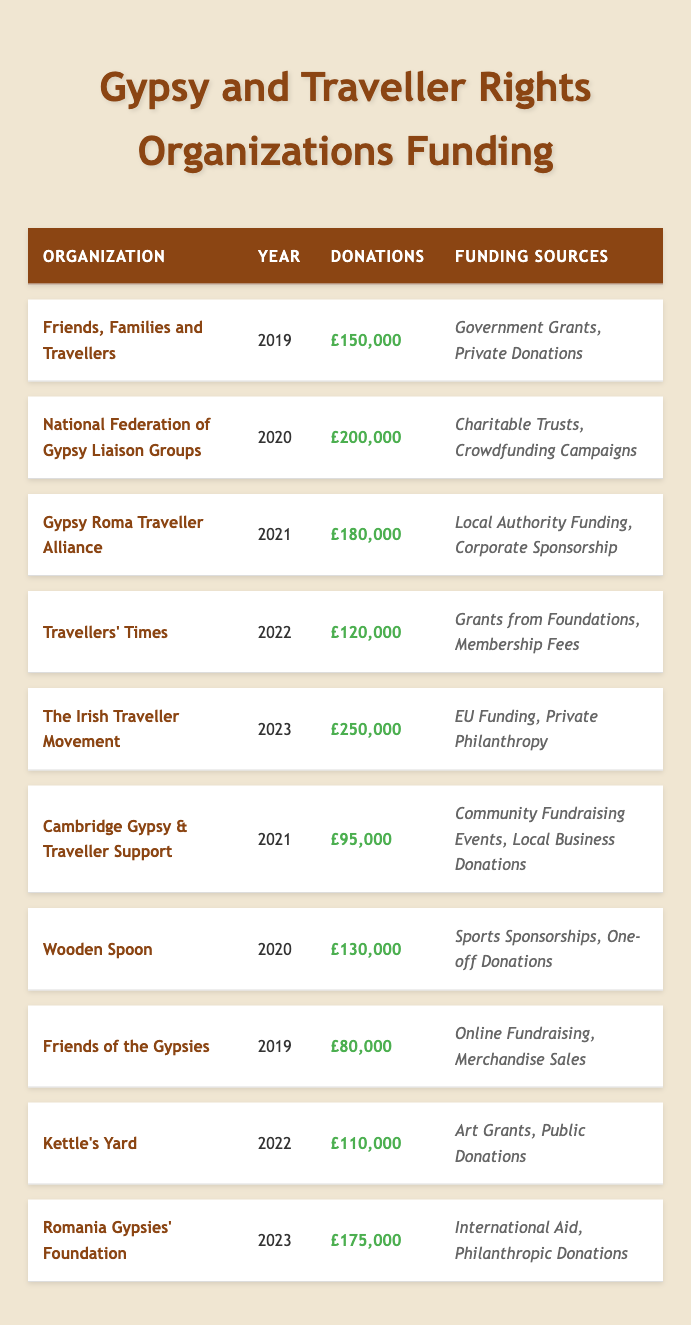What was the total amount of donations for 2020? In 2020, the donations were £200,000 from the National Federation of Gypsy Liaison Groups and £130,000 from Wooden Spoon. Summing these amounts gives £200,000 + £130,000 = £330,000.
Answer: £330,000 Which organization received the highest donations in 2023? The Irish Traveller Movement received the highest donations in 2023, totaling £250,000.
Answer: The Irish Traveller Movement How many organizations got funding from private donations? Friends, Families and Travellers, The Irish Traveller Movement, and Friends of the Gypsies received funding from private donations. This is a total of three organizations.
Answer: 3 What was the average amount of donations for the organizations in 2021? The organizations in 2021 are Gypsy Roma Traveller Alliance (£180,000) and Cambridge Gypsy & Traveller Support (£95,000). The total donations are £180,000 + £95,000 = £275,000, and there are 2 organizations, so the average is £275,000 / 2 = £137,500.
Answer: £137,500 Which funding source was common for the organizations supported in 2019? The organizations in 2019 were Friends, Families and Travellers and Friends of the Gypsies. Friends, Families and Travellers received funding from Government Grants and Private Donations, while Friends of the Gypsies had Online Fundraising and Merchandise Sales. Thus, there are no common funding sources for the year.
Answer: No What was the total donations amount across all organizations for the year 2022? The organizations in 2022 are Travellers' Times (£120,000) and Kettle's Yard (£110,000). Adding these gives £120,000 + £110,000 = £230,000.
Answer: £230,000 Did any organizations receive funding exclusively from community fundraising events? None of the organizations listed received funding exclusively from community fundraising events; Cambridge Gypsy & Traveller Support received funding from Community Fundraising Events and Local Business Donations, indicating there were other funding sources.
Answer: No Which year had the least amount of total donations and how much was it? In 2019, Friends, Families and Travellers had £150,000 and Friends of the Gypsies had £80,000. The total is £150,000 + £80,000 = £230,000. This is lesser than any other year's total donations.
Answer: £230,000 in 2019 What is the difference in donations between the highest and lowest funded organization in 2023? The Irish Traveller Movement received £250,000 and Romania Gypsies' Foundation received £175,000 in 2023. The difference is £250,000 - £175,000 = £75,000.
Answer: £75,000 Which funding source was the most common across all organizations? By reviewing the funding sources listed, several types appear, but private donations (present in Friends, Families and Travellers; The Irish Traveller Movement) and government grants appear frequently, though other funding types are seen as well. There is no definitive most common source in the dataset.
Answer: Not definitive How many organizations received government grants over the past five years? Only Friends, Families and Travellers received government grants in 2019. None of the remaining organizations listed received funding labelled as government grants in the dataset.
Answer: 1 